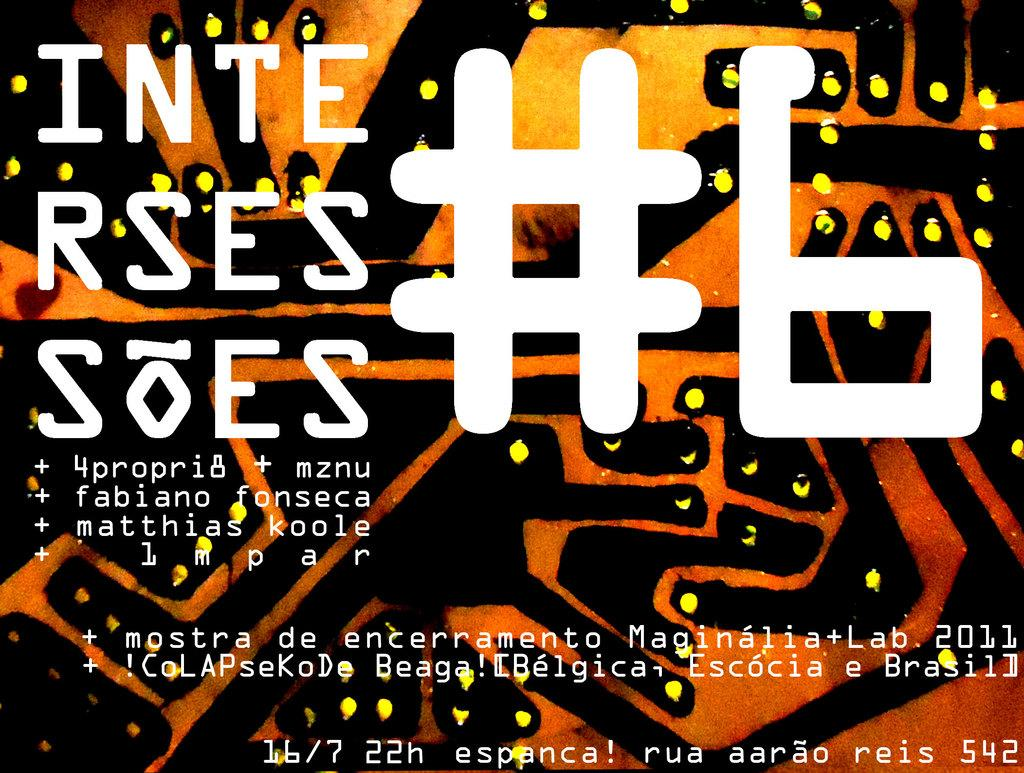<image>
Relay a brief, clear account of the picture shown. A black and orange sign has # 6 in white text. 